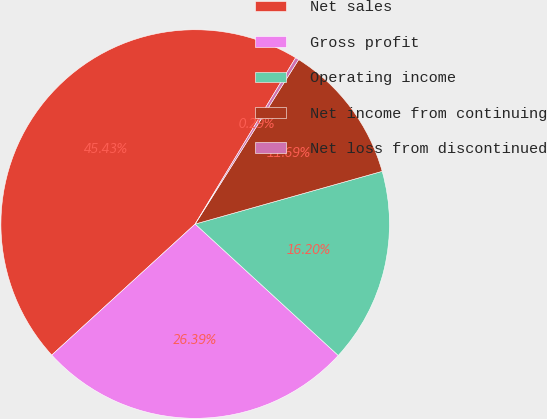Convert chart. <chart><loc_0><loc_0><loc_500><loc_500><pie_chart><fcel>Net sales<fcel>Gross profit<fcel>Operating income<fcel>Net income from continuing<fcel>Net loss from discontinued<nl><fcel>45.43%<fcel>26.39%<fcel>16.2%<fcel>11.69%<fcel>0.29%<nl></chart> 